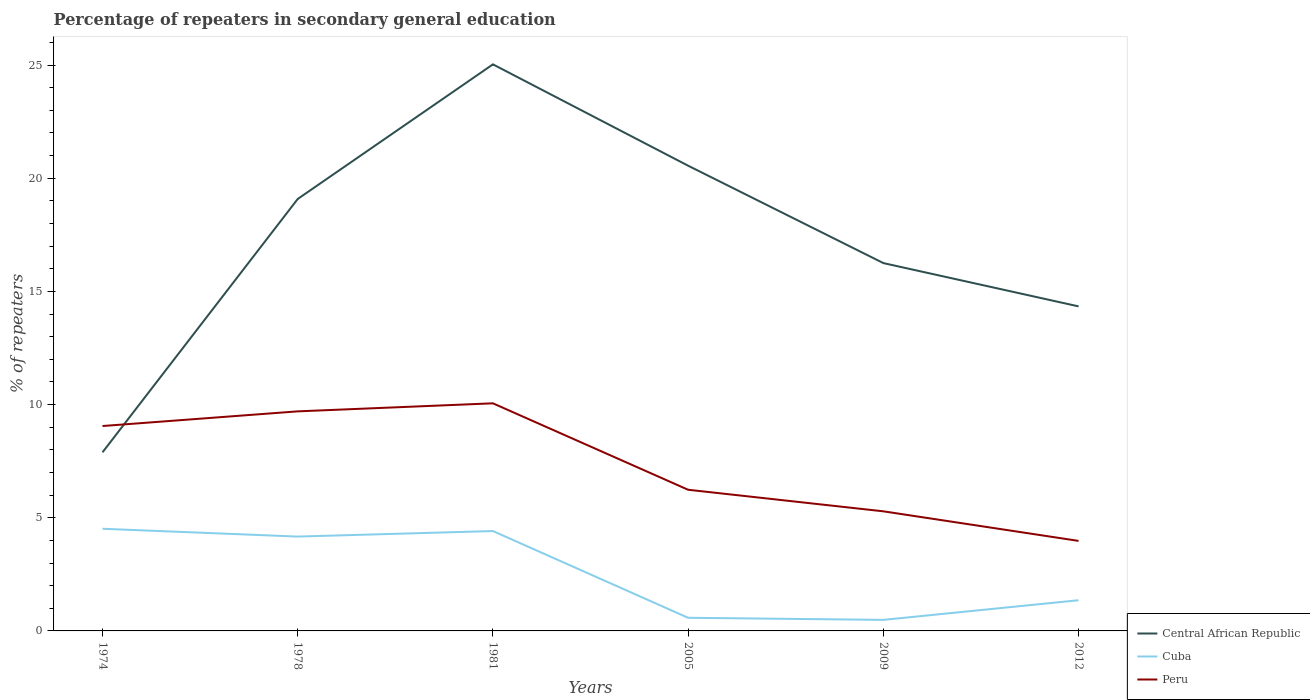Does the line corresponding to Peru intersect with the line corresponding to Central African Republic?
Provide a short and direct response. Yes. Across all years, what is the maximum percentage of repeaters in secondary general education in Cuba?
Your response must be concise. 0.49. In which year was the percentage of repeaters in secondary general education in Peru maximum?
Your answer should be very brief. 2012. What is the total percentage of repeaters in secondary general education in Central African Republic in the graph?
Offer a very short reply. -6.45. What is the difference between the highest and the second highest percentage of repeaters in secondary general education in Peru?
Offer a terse response. 6.08. What is the difference between the highest and the lowest percentage of repeaters in secondary general education in Central African Republic?
Your answer should be very brief. 3. Is the percentage of repeaters in secondary general education in Central African Republic strictly greater than the percentage of repeaters in secondary general education in Peru over the years?
Your answer should be compact. No. How many lines are there?
Give a very brief answer. 3. What is the difference between two consecutive major ticks on the Y-axis?
Provide a short and direct response. 5. Are the values on the major ticks of Y-axis written in scientific E-notation?
Keep it short and to the point. No. Where does the legend appear in the graph?
Keep it short and to the point. Bottom right. How are the legend labels stacked?
Ensure brevity in your answer.  Vertical. What is the title of the graph?
Ensure brevity in your answer.  Percentage of repeaters in secondary general education. Does "Lithuania" appear as one of the legend labels in the graph?
Make the answer very short. No. What is the label or title of the X-axis?
Make the answer very short. Years. What is the label or title of the Y-axis?
Your answer should be compact. % of repeaters. What is the % of repeaters in Central African Republic in 1974?
Give a very brief answer. 7.89. What is the % of repeaters in Cuba in 1974?
Offer a terse response. 4.51. What is the % of repeaters in Peru in 1974?
Give a very brief answer. 9.05. What is the % of repeaters of Central African Republic in 1978?
Ensure brevity in your answer.  19.08. What is the % of repeaters in Cuba in 1978?
Offer a terse response. 4.17. What is the % of repeaters of Peru in 1978?
Your answer should be very brief. 9.7. What is the % of repeaters of Central African Republic in 1981?
Ensure brevity in your answer.  25.03. What is the % of repeaters in Cuba in 1981?
Keep it short and to the point. 4.41. What is the % of repeaters of Peru in 1981?
Offer a terse response. 10.06. What is the % of repeaters of Central African Republic in 2005?
Your response must be concise. 20.55. What is the % of repeaters of Cuba in 2005?
Offer a very short reply. 0.58. What is the % of repeaters in Peru in 2005?
Provide a short and direct response. 6.24. What is the % of repeaters of Central African Republic in 2009?
Provide a short and direct response. 16.25. What is the % of repeaters in Cuba in 2009?
Offer a very short reply. 0.49. What is the % of repeaters of Peru in 2009?
Make the answer very short. 5.28. What is the % of repeaters in Central African Republic in 2012?
Provide a short and direct response. 14.34. What is the % of repeaters in Cuba in 2012?
Offer a very short reply. 1.36. What is the % of repeaters in Peru in 2012?
Provide a short and direct response. 3.98. Across all years, what is the maximum % of repeaters of Central African Republic?
Provide a short and direct response. 25.03. Across all years, what is the maximum % of repeaters in Cuba?
Offer a very short reply. 4.51. Across all years, what is the maximum % of repeaters of Peru?
Your answer should be very brief. 10.06. Across all years, what is the minimum % of repeaters of Central African Republic?
Offer a very short reply. 7.89. Across all years, what is the minimum % of repeaters of Cuba?
Provide a short and direct response. 0.49. Across all years, what is the minimum % of repeaters in Peru?
Offer a terse response. 3.98. What is the total % of repeaters in Central African Republic in the graph?
Make the answer very short. 103.15. What is the total % of repeaters in Cuba in the graph?
Keep it short and to the point. 15.52. What is the total % of repeaters of Peru in the graph?
Your response must be concise. 44.31. What is the difference between the % of repeaters of Central African Republic in 1974 and that in 1978?
Provide a succinct answer. -11.19. What is the difference between the % of repeaters of Cuba in 1974 and that in 1978?
Make the answer very short. 0.34. What is the difference between the % of repeaters of Peru in 1974 and that in 1978?
Offer a very short reply. -0.65. What is the difference between the % of repeaters in Central African Republic in 1974 and that in 1981?
Make the answer very short. -17.14. What is the difference between the % of repeaters in Cuba in 1974 and that in 1981?
Your response must be concise. 0.1. What is the difference between the % of repeaters of Peru in 1974 and that in 1981?
Offer a terse response. -1. What is the difference between the % of repeaters in Central African Republic in 1974 and that in 2005?
Offer a terse response. -12.66. What is the difference between the % of repeaters in Cuba in 1974 and that in 2005?
Keep it short and to the point. 3.93. What is the difference between the % of repeaters of Peru in 1974 and that in 2005?
Ensure brevity in your answer.  2.82. What is the difference between the % of repeaters in Central African Republic in 1974 and that in 2009?
Make the answer very short. -8.36. What is the difference between the % of repeaters of Cuba in 1974 and that in 2009?
Provide a succinct answer. 4.03. What is the difference between the % of repeaters in Peru in 1974 and that in 2009?
Keep it short and to the point. 3.77. What is the difference between the % of repeaters of Central African Republic in 1974 and that in 2012?
Provide a succinct answer. -6.45. What is the difference between the % of repeaters in Cuba in 1974 and that in 2012?
Provide a short and direct response. 3.16. What is the difference between the % of repeaters in Peru in 1974 and that in 2012?
Your response must be concise. 5.08. What is the difference between the % of repeaters in Central African Republic in 1978 and that in 1981?
Your answer should be compact. -5.95. What is the difference between the % of repeaters in Cuba in 1978 and that in 1981?
Give a very brief answer. -0.24. What is the difference between the % of repeaters in Peru in 1978 and that in 1981?
Give a very brief answer. -0.36. What is the difference between the % of repeaters in Central African Republic in 1978 and that in 2005?
Provide a succinct answer. -1.47. What is the difference between the % of repeaters in Cuba in 1978 and that in 2005?
Your answer should be compact. 3.59. What is the difference between the % of repeaters of Peru in 1978 and that in 2005?
Your answer should be compact. 3.46. What is the difference between the % of repeaters of Central African Republic in 1978 and that in 2009?
Your response must be concise. 2.83. What is the difference between the % of repeaters of Cuba in 1978 and that in 2009?
Offer a very short reply. 3.68. What is the difference between the % of repeaters in Peru in 1978 and that in 2009?
Provide a short and direct response. 4.42. What is the difference between the % of repeaters in Central African Republic in 1978 and that in 2012?
Provide a short and direct response. 4.75. What is the difference between the % of repeaters in Cuba in 1978 and that in 2012?
Keep it short and to the point. 2.81. What is the difference between the % of repeaters of Peru in 1978 and that in 2012?
Offer a terse response. 5.72. What is the difference between the % of repeaters in Central African Republic in 1981 and that in 2005?
Keep it short and to the point. 4.48. What is the difference between the % of repeaters in Cuba in 1981 and that in 2005?
Offer a very short reply. 3.83. What is the difference between the % of repeaters in Peru in 1981 and that in 2005?
Your answer should be very brief. 3.82. What is the difference between the % of repeaters of Central African Republic in 1981 and that in 2009?
Your answer should be very brief. 8.78. What is the difference between the % of repeaters in Cuba in 1981 and that in 2009?
Your answer should be compact. 3.92. What is the difference between the % of repeaters of Peru in 1981 and that in 2009?
Your response must be concise. 4.77. What is the difference between the % of repeaters in Central African Republic in 1981 and that in 2012?
Give a very brief answer. 10.69. What is the difference between the % of repeaters in Cuba in 1981 and that in 2012?
Keep it short and to the point. 3.06. What is the difference between the % of repeaters in Peru in 1981 and that in 2012?
Make the answer very short. 6.08. What is the difference between the % of repeaters in Central African Republic in 2005 and that in 2009?
Your answer should be very brief. 4.3. What is the difference between the % of repeaters of Cuba in 2005 and that in 2009?
Make the answer very short. 0.09. What is the difference between the % of repeaters in Peru in 2005 and that in 2009?
Your response must be concise. 0.95. What is the difference between the % of repeaters of Central African Republic in 2005 and that in 2012?
Provide a short and direct response. 6.22. What is the difference between the % of repeaters of Cuba in 2005 and that in 2012?
Your answer should be compact. -0.78. What is the difference between the % of repeaters in Peru in 2005 and that in 2012?
Provide a short and direct response. 2.26. What is the difference between the % of repeaters of Central African Republic in 2009 and that in 2012?
Ensure brevity in your answer.  1.91. What is the difference between the % of repeaters of Cuba in 2009 and that in 2012?
Offer a very short reply. -0.87. What is the difference between the % of repeaters of Peru in 2009 and that in 2012?
Offer a terse response. 1.31. What is the difference between the % of repeaters in Central African Republic in 1974 and the % of repeaters in Cuba in 1978?
Provide a short and direct response. 3.72. What is the difference between the % of repeaters of Central African Republic in 1974 and the % of repeaters of Peru in 1978?
Keep it short and to the point. -1.81. What is the difference between the % of repeaters of Cuba in 1974 and the % of repeaters of Peru in 1978?
Offer a very short reply. -5.19. What is the difference between the % of repeaters of Central African Republic in 1974 and the % of repeaters of Cuba in 1981?
Make the answer very short. 3.48. What is the difference between the % of repeaters in Central African Republic in 1974 and the % of repeaters in Peru in 1981?
Offer a terse response. -2.16. What is the difference between the % of repeaters in Cuba in 1974 and the % of repeaters in Peru in 1981?
Make the answer very short. -5.54. What is the difference between the % of repeaters in Central African Republic in 1974 and the % of repeaters in Cuba in 2005?
Keep it short and to the point. 7.31. What is the difference between the % of repeaters in Central African Republic in 1974 and the % of repeaters in Peru in 2005?
Keep it short and to the point. 1.66. What is the difference between the % of repeaters of Cuba in 1974 and the % of repeaters of Peru in 2005?
Provide a succinct answer. -1.72. What is the difference between the % of repeaters in Central African Republic in 1974 and the % of repeaters in Cuba in 2009?
Offer a very short reply. 7.4. What is the difference between the % of repeaters in Central African Republic in 1974 and the % of repeaters in Peru in 2009?
Offer a very short reply. 2.61. What is the difference between the % of repeaters in Cuba in 1974 and the % of repeaters in Peru in 2009?
Your answer should be compact. -0.77. What is the difference between the % of repeaters in Central African Republic in 1974 and the % of repeaters in Cuba in 2012?
Provide a succinct answer. 6.54. What is the difference between the % of repeaters of Central African Republic in 1974 and the % of repeaters of Peru in 2012?
Your answer should be very brief. 3.91. What is the difference between the % of repeaters in Cuba in 1974 and the % of repeaters in Peru in 2012?
Keep it short and to the point. 0.54. What is the difference between the % of repeaters in Central African Republic in 1978 and the % of repeaters in Cuba in 1981?
Provide a short and direct response. 14.67. What is the difference between the % of repeaters of Central African Republic in 1978 and the % of repeaters of Peru in 1981?
Give a very brief answer. 9.03. What is the difference between the % of repeaters of Cuba in 1978 and the % of repeaters of Peru in 1981?
Make the answer very short. -5.89. What is the difference between the % of repeaters of Central African Republic in 1978 and the % of repeaters of Cuba in 2005?
Make the answer very short. 18.5. What is the difference between the % of repeaters of Central African Republic in 1978 and the % of repeaters of Peru in 2005?
Provide a short and direct response. 12.85. What is the difference between the % of repeaters of Cuba in 1978 and the % of repeaters of Peru in 2005?
Keep it short and to the point. -2.07. What is the difference between the % of repeaters in Central African Republic in 1978 and the % of repeaters in Cuba in 2009?
Your response must be concise. 18.6. What is the difference between the % of repeaters of Central African Republic in 1978 and the % of repeaters of Peru in 2009?
Provide a short and direct response. 13.8. What is the difference between the % of repeaters in Cuba in 1978 and the % of repeaters in Peru in 2009?
Provide a succinct answer. -1.12. What is the difference between the % of repeaters in Central African Republic in 1978 and the % of repeaters in Cuba in 2012?
Give a very brief answer. 17.73. What is the difference between the % of repeaters in Central African Republic in 1978 and the % of repeaters in Peru in 2012?
Provide a short and direct response. 15.11. What is the difference between the % of repeaters of Cuba in 1978 and the % of repeaters of Peru in 2012?
Offer a terse response. 0.19. What is the difference between the % of repeaters of Central African Republic in 1981 and the % of repeaters of Cuba in 2005?
Your response must be concise. 24.45. What is the difference between the % of repeaters in Central African Republic in 1981 and the % of repeaters in Peru in 2005?
Offer a very short reply. 18.79. What is the difference between the % of repeaters of Cuba in 1981 and the % of repeaters of Peru in 2005?
Offer a terse response. -1.82. What is the difference between the % of repeaters in Central African Republic in 1981 and the % of repeaters in Cuba in 2009?
Offer a very short reply. 24.54. What is the difference between the % of repeaters of Central African Republic in 1981 and the % of repeaters of Peru in 2009?
Your answer should be very brief. 19.75. What is the difference between the % of repeaters of Cuba in 1981 and the % of repeaters of Peru in 2009?
Give a very brief answer. -0.87. What is the difference between the % of repeaters in Central African Republic in 1981 and the % of repeaters in Cuba in 2012?
Keep it short and to the point. 23.68. What is the difference between the % of repeaters in Central African Republic in 1981 and the % of repeaters in Peru in 2012?
Offer a very short reply. 21.05. What is the difference between the % of repeaters of Cuba in 1981 and the % of repeaters of Peru in 2012?
Make the answer very short. 0.43. What is the difference between the % of repeaters in Central African Republic in 2005 and the % of repeaters in Cuba in 2009?
Provide a short and direct response. 20.07. What is the difference between the % of repeaters of Central African Republic in 2005 and the % of repeaters of Peru in 2009?
Ensure brevity in your answer.  15.27. What is the difference between the % of repeaters of Cuba in 2005 and the % of repeaters of Peru in 2009?
Keep it short and to the point. -4.7. What is the difference between the % of repeaters in Central African Republic in 2005 and the % of repeaters in Cuba in 2012?
Offer a terse response. 19.2. What is the difference between the % of repeaters in Central African Republic in 2005 and the % of repeaters in Peru in 2012?
Ensure brevity in your answer.  16.58. What is the difference between the % of repeaters in Cuba in 2005 and the % of repeaters in Peru in 2012?
Provide a succinct answer. -3.4. What is the difference between the % of repeaters in Central African Republic in 2009 and the % of repeaters in Cuba in 2012?
Ensure brevity in your answer.  14.9. What is the difference between the % of repeaters of Central African Republic in 2009 and the % of repeaters of Peru in 2012?
Your answer should be compact. 12.27. What is the difference between the % of repeaters in Cuba in 2009 and the % of repeaters in Peru in 2012?
Your answer should be compact. -3.49. What is the average % of repeaters of Central African Republic per year?
Ensure brevity in your answer.  17.19. What is the average % of repeaters in Cuba per year?
Keep it short and to the point. 2.59. What is the average % of repeaters in Peru per year?
Ensure brevity in your answer.  7.38. In the year 1974, what is the difference between the % of repeaters in Central African Republic and % of repeaters in Cuba?
Your answer should be very brief. 3.38. In the year 1974, what is the difference between the % of repeaters of Central African Republic and % of repeaters of Peru?
Offer a very short reply. -1.16. In the year 1974, what is the difference between the % of repeaters of Cuba and % of repeaters of Peru?
Ensure brevity in your answer.  -4.54. In the year 1978, what is the difference between the % of repeaters of Central African Republic and % of repeaters of Cuba?
Your answer should be compact. 14.92. In the year 1978, what is the difference between the % of repeaters of Central African Republic and % of repeaters of Peru?
Provide a short and direct response. 9.38. In the year 1978, what is the difference between the % of repeaters in Cuba and % of repeaters in Peru?
Keep it short and to the point. -5.53. In the year 1981, what is the difference between the % of repeaters in Central African Republic and % of repeaters in Cuba?
Offer a very short reply. 20.62. In the year 1981, what is the difference between the % of repeaters of Central African Republic and % of repeaters of Peru?
Offer a very short reply. 14.98. In the year 1981, what is the difference between the % of repeaters of Cuba and % of repeaters of Peru?
Give a very brief answer. -5.64. In the year 2005, what is the difference between the % of repeaters in Central African Republic and % of repeaters in Cuba?
Ensure brevity in your answer.  19.97. In the year 2005, what is the difference between the % of repeaters in Central African Republic and % of repeaters in Peru?
Provide a succinct answer. 14.32. In the year 2005, what is the difference between the % of repeaters in Cuba and % of repeaters in Peru?
Make the answer very short. -5.66. In the year 2009, what is the difference between the % of repeaters of Central African Republic and % of repeaters of Cuba?
Your answer should be compact. 15.76. In the year 2009, what is the difference between the % of repeaters of Central African Republic and % of repeaters of Peru?
Offer a terse response. 10.97. In the year 2009, what is the difference between the % of repeaters of Cuba and % of repeaters of Peru?
Provide a succinct answer. -4.8. In the year 2012, what is the difference between the % of repeaters in Central African Republic and % of repeaters in Cuba?
Provide a short and direct response. 12.98. In the year 2012, what is the difference between the % of repeaters in Central African Republic and % of repeaters in Peru?
Your response must be concise. 10.36. In the year 2012, what is the difference between the % of repeaters in Cuba and % of repeaters in Peru?
Provide a succinct answer. -2.62. What is the ratio of the % of repeaters in Central African Republic in 1974 to that in 1978?
Your answer should be compact. 0.41. What is the ratio of the % of repeaters in Cuba in 1974 to that in 1978?
Keep it short and to the point. 1.08. What is the ratio of the % of repeaters of Peru in 1974 to that in 1978?
Your answer should be compact. 0.93. What is the ratio of the % of repeaters of Central African Republic in 1974 to that in 1981?
Keep it short and to the point. 0.32. What is the ratio of the % of repeaters of Cuba in 1974 to that in 1981?
Offer a very short reply. 1.02. What is the ratio of the % of repeaters in Peru in 1974 to that in 1981?
Offer a terse response. 0.9. What is the ratio of the % of repeaters of Central African Republic in 1974 to that in 2005?
Your answer should be very brief. 0.38. What is the ratio of the % of repeaters in Cuba in 1974 to that in 2005?
Your response must be concise. 7.78. What is the ratio of the % of repeaters of Peru in 1974 to that in 2005?
Your answer should be very brief. 1.45. What is the ratio of the % of repeaters of Central African Republic in 1974 to that in 2009?
Offer a terse response. 0.49. What is the ratio of the % of repeaters in Cuba in 1974 to that in 2009?
Your response must be concise. 9.25. What is the ratio of the % of repeaters in Peru in 1974 to that in 2009?
Offer a very short reply. 1.71. What is the ratio of the % of repeaters of Central African Republic in 1974 to that in 2012?
Offer a very short reply. 0.55. What is the ratio of the % of repeaters in Cuba in 1974 to that in 2012?
Provide a short and direct response. 3.33. What is the ratio of the % of repeaters of Peru in 1974 to that in 2012?
Make the answer very short. 2.28. What is the ratio of the % of repeaters in Central African Republic in 1978 to that in 1981?
Keep it short and to the point. 0.76. What is the ratio of the % of repeaters in Cuba in 1978 to that in 1981?
Make the answer very short. 0.94. What is the ratio of the % of repeaters in Peru in 1978 to that in 1981?
Give a very brief answer. 0.96. What is the ratio of the % of repeaters in Central African Republic in 1978 to that in 2005?
Give a very brief answer. 0.93. What is the ratio of the % of repeaters of Cuba in 1978 to that in 2005?
Your response must be concise. 7.18. What is the ratio of the % of repeaters in Peru in 1978 to that in 2005?
Provide a short and direct response. 1.56. What is the ratio of the % of repeaters of Central African Republic in 1978 to that in 2009?
Give a very brief answer. 1.17. What is the ratio of the % of repeaters of Cuba in 1978 to that in 2009?
Make the answer very short. 8.54. What is the ratio of the % of repeaters of Peru in 1978 to that in 2009?
Provide a succinct answer. 1.84. What is the ratio of the % of repeaters of Central African Republic in 1978 to that in 2012?
Offer a very short reply. 1.33. What is the ratio of the % of repeaters in Cuba in 1978 to that in 2012?
Provide a succinct answer. 3.07. What is the ratio of the % of repeaters in Peru in 1978 to that in 2012?
Keep it short and to the point. 2.44. What is the ratio of the % of repeaters in Central African Republic in 1981 to that in 2005?
Offer a very short reply. 1.22. What is the ratio of the % of repeaters in Cuba in 1981 to that in 2005?
Make the answer very short. 7.6. What is the ratio of the % of repeaters of Peru in 1981 to that in 2005?
Make the answer very short. 1.61. What is the ratio of the % of repeaters in Central African Republic in 1981 to that in 2009?
Make the answer very short. 1.54. What is the ratio of the % of repeaters in Cuba in 1981 to that in 2009?
Your response must be concise. 9.04. What is the ratio of the % of repeaters of Peru in 1981 to that in 2009?
Keep it short and to the point. 1.9. What is the ratio of the % of repeaters of Central African Republic in 1981 to that in 2012?
Give a very brief answer. 1.75. What is the ratio of the % of repeaters of Cuba in 1981 to that in 2012?
Offer a very short reply. 3.25. What is the ratio of the % of repeaters in Peru in 1981 to that in 2012?
Your response must be concise. 2.53. What is the ratio of the % of repeaters in Central African Republic in 2005 to that in 2009?
Ensure brevity in your answer.  1.26. What is the ratio of the % of repeaters of Cuba in 2005 to that in 2009?
Keep it short and to the point. 1.19. What is the ratio of the % of repeaters in Peru in 2005 to that in 2009?
Offer a terse response. 1.18. What is the ratio of the % of repeaters of Central African Republic in 2005 to that in 2012?
Keep it short and to the point. 1.43. What is the ratio of the % of repeaters of Cuba in 2005 to that in 2012?
Make the answer very short. 0.43. What is the ratio of the % of repeaters in Peru in 2005 to that in 2012?
Offer a very short reply. 1.57. What is the ratio of the % of repeaters in Central African Republic in 2009 to that in 2012?
Your response must be concise. 1.13. What is the ratio of the % of repeaters of Cuba in 2009 to that in 2012?
Your answer should be very brief. 0.36. What is the ratio of the % of repeaters in Peru in 2009 to that in 2012?
Your response must be concise. 1.33. What is the difference between the highest and the second highest % of repeaters of Central African Republic?
Your answer should be very brief. 4.48. What is the difference between the highest and the second highest % of repeaters in Cuba?
Your response must be concise. 0.1. What is the difference between the highest and the second highest % of repeaters in Peru?
Your response must be concise. 0.36. What is the difference between the highest and the lowest % of repeaters of Central African Republic?
Offer a terse response. 17.14. What is the difference between the highest and the lowest % of repeaters in Cuba?
Keep it short and to the point. 4.03. What is the difference between the highest and the lowest % of repeaters in Peru?
Your response must be concise. 6.08. 